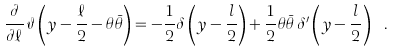<formula> <loc_0><loc_0><loc_500><loc_500>\frac { \partial } { \partial \ell } \, \vartheta \left ( y - \frac { \ell } { 2 } - \theta \bar { \theta } \right ) = - \frac { 1 } { 2 } \delta \left ( y - \frac { l } { 2 } \right ) + \frac { 1 } { 2 } \theta \bar { \theta } \, \delta ^ { \prime } \left ( y - \frac { l } { 2 } \right ) \ .</formula> 